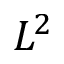Convert formula to latex. <formula><loc_0><loc_0><loc_500><loc_500>L ^ { 2 }</formula> 